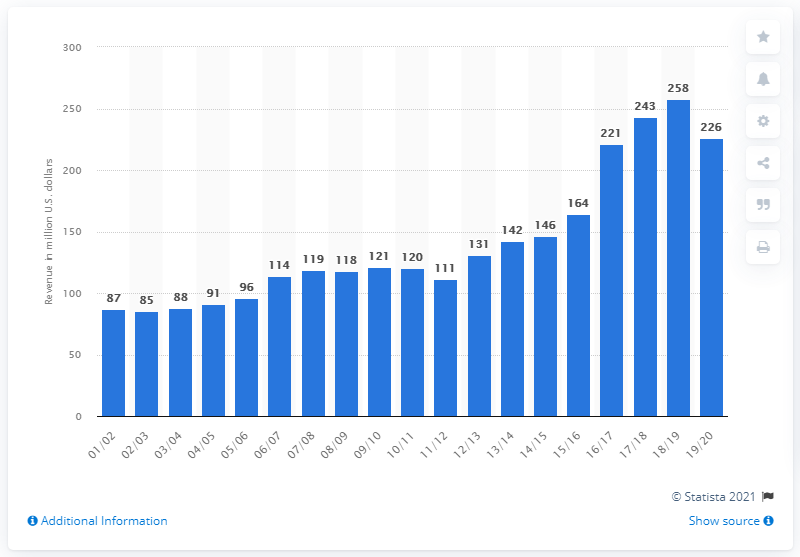Give some essential details in this illustration. In the 2019/2020 season, the estimated revenue of the Utah Jazz was approximately 226 million dollars. 